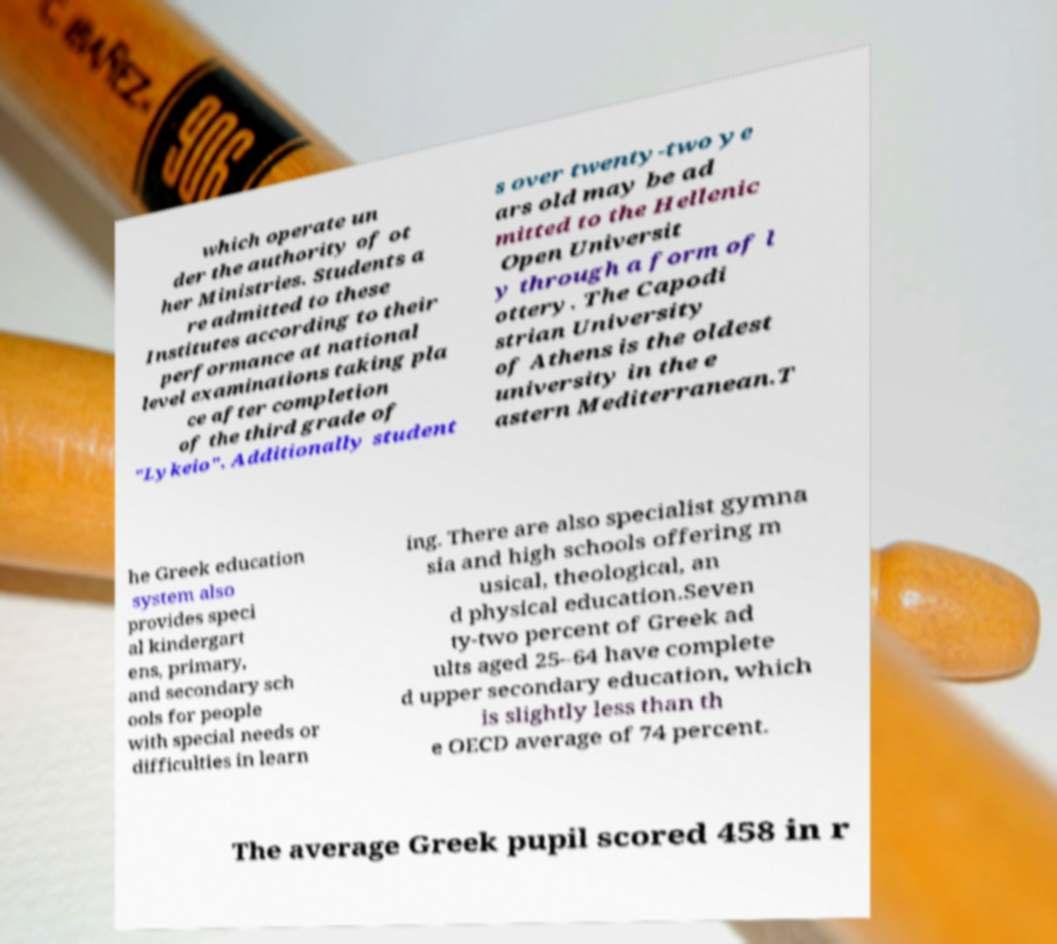Could you extract and type out the text from this image? which operate un der the authority of ot her Ministries. Students a re admitted to these Institutes according to their performance at national level examinations taking pla ce after completion of the third grade of "Lykeio". Additionally student s over twenty-two ye ars old may be ad mitted to the Hellenic Open Universit y through a form of l ottery. The Capodi strian University of Athens is the oldest university in the e astern Mediterranean.T he Greek education system also provides speci al kindergart ens, primary, and secondary sch ools for people with special needs or difficulties in learn ing. There are also specialist gymna sia and high schools offering m usical, theological, an d physical education.Seven ty-two percent of Greek ad ults aged 25–64 have complete d upper secondary education, which is slightly less than th e OECD average of 74 percent. The average Greek pupil scored 458 in r 